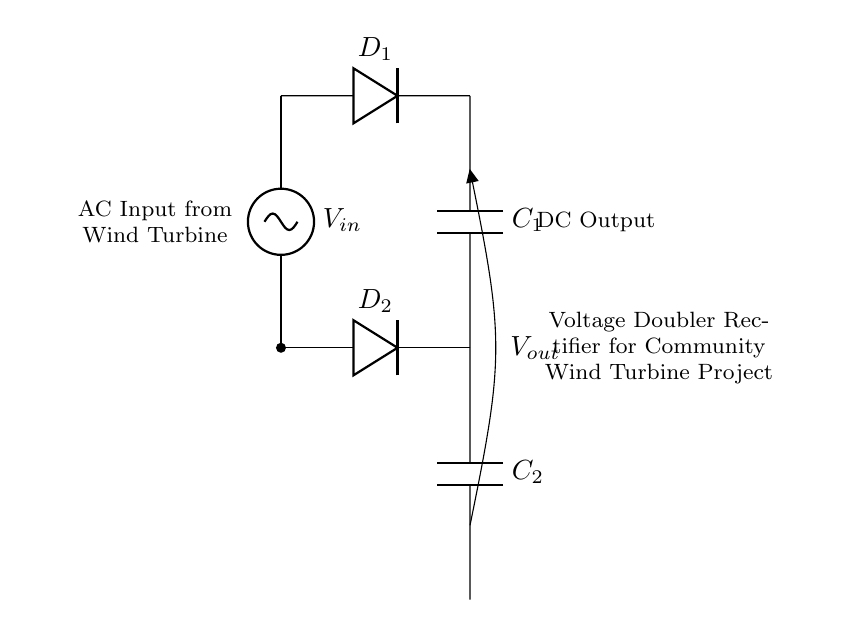What is the type of circuit shown? The circuit is a voltage doubler rectifier, which is specifically designed to convert AC voltage into a higher DC voltage by utilizing capacitors and diodes in a particular configuration.
Answer: voltage doubler rectifier What components are involved in this circuit? The involved components include two diodes (D1 and D2) and two capacitors (C1 and C2). These components work together to rectify and smooth the AC input into a higher DC output.
Answer: diodes and capacitors What is the output type of this circuit? The circuit produces a direct current (DC) output, which is achieved after the rectification process that converts the AC input voltage.
Answer: DC How many diodes are used in this circuit? There are two diodes (D1 and D2) in this voltage doubler rectifier circuit, and each diode plays a role in the rectification of the input voltage.
Answer: 2 What role do the capacitors play in this circuit? The capacitors (C1 and C2) store charge and help to smooth the output voltage, thereby increasing the efficiency of the voltage doubling action.
Answer: store charge and smooth output What is the input source of this circuit? The input source is an alternating current (AC) signal that comes from the wind turbine, which is the primary source of energy for the rectifier circuit.
Answer: AC input from wind turbine What is the purpose of the voltage doubler configuration in this circuit? The voltage doubler configuration is designed to increase the voltage output from the AC input, effectively doubling the voltage which enhances the efficiency of the wind turbine's energy conversion.
Answer: increase voltage output 